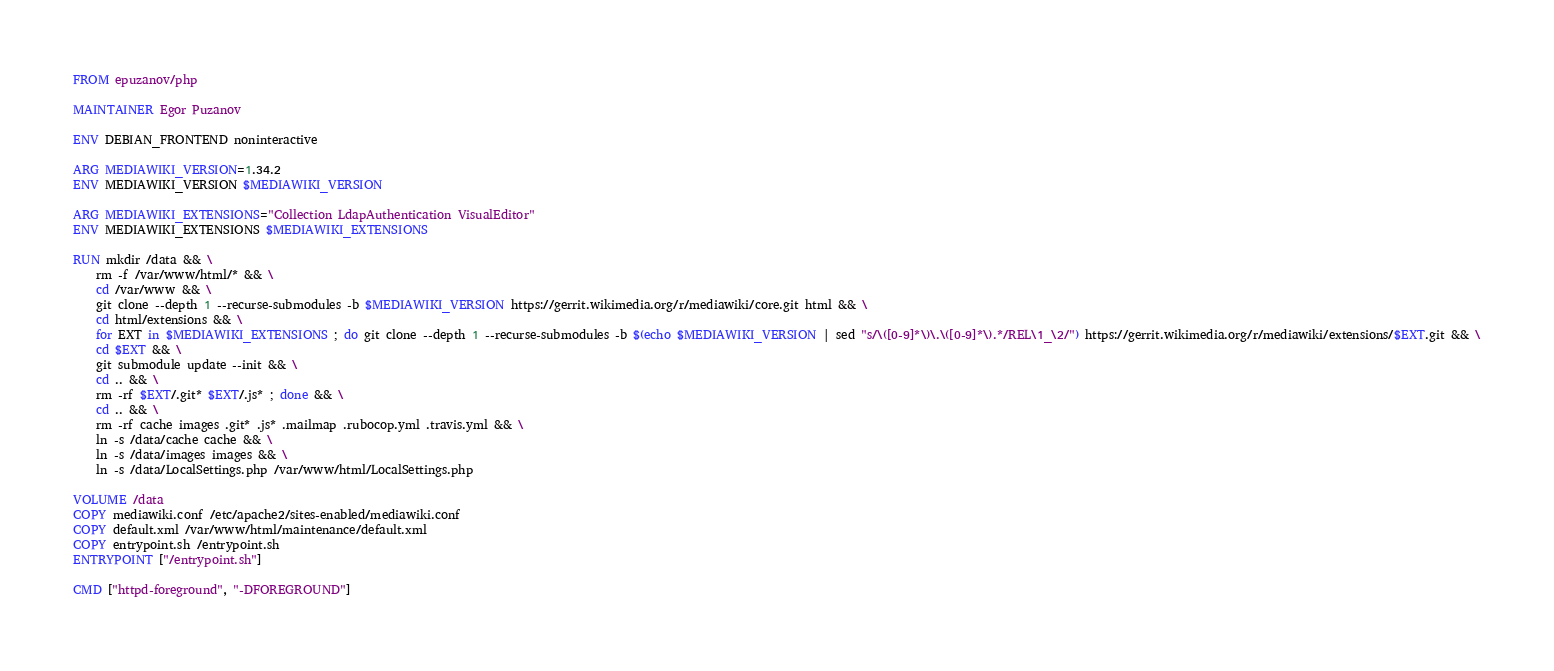<code> <loc_0><loc_0><loc_500><loc_500><_Dockerfile_>FROM epuzanov/php

MAINTAINER Egor Puzanov

ENV DEBIAN_FRONTEND noninteractive

ARG MEDIAWIKI_VERSION=1.34.2
ENV MEDIAWIKI_VERSION $MEDIAWIKI_VERSION

ARG MEDIAWIKI_EXTENSIONS="Collection LdapAuthentication VisualEditor"
ENV MEDIAWIKI_EXTENSIONS $MEDIAWIKI_EXTENSIONS

RUN mkdir /data && \
    rm -f /var/www/html/* && \
    cd /var/www && \
    git clone --depth 1 --recurse-submodules -b $MEDIAWIKI_VERSION https://gerrit.wikimedia.org/r/mediawiki/core.git html && \
    cd html/extensions && \
    for EXT in $MEDIAWIKI_EXTENSIONS ; do git clone --depth 1 --recurse-submodules -b $(echo $MEDIAWIKI_VERSION | sed "s/\([0-9]*\)\.\([0-9]*\).*/REL\1_\2/") https://gerrit.wikimedia.org/r/mediawiki/extensions/$EXT.git && \
    cd $EXT && \
    git submodule update --init && \
    cd .. && \
    rm -rf $EXT/.git* $EXT/.js* ; done && \
    cd .. && \
    rm -rf cache images .git* .js* .mailmap .rubocop.yml .travis.yml && \
    ln -s /data/cache cache && \
    ln -s /data/images images && \
    ln -s /data/LocalSettings.php /var/www/html/LocalSettings.php

VOLUME /data
COPY mediawiki.conf /etc/apache2/sites-enabled/mediawiki.conf
COPY default.xml /var/www/html/maintenance/default.xml
COPY entrypoint.sh /entrypoint.sh
ENTRYPOINT ["/entrypoint.sh"]

CMD ["httpd-foreground", "-DFOREGROUND"]
</code> 